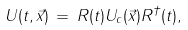Convert formula to latex. <formula><loc_0><loc_0><loc_500><loc_500>U ( t , \vec { x } ) \, = \, R ( t ) U _ { c } ( \vec { x } ) R ^ { \dagger } ( t ) ,</formula> 